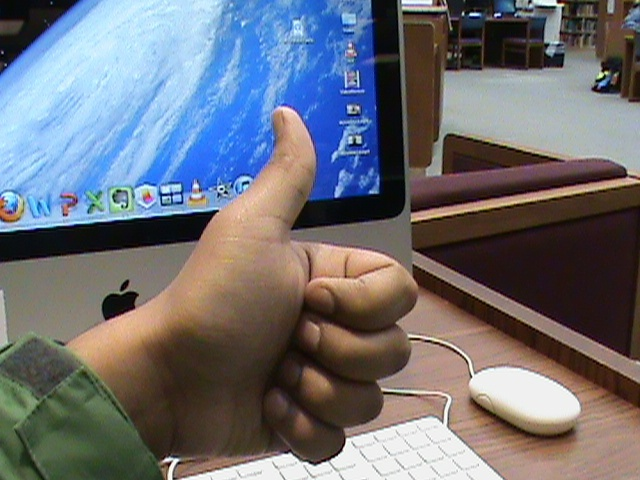Describe the objects in this image and their specific colors. I can see tv in black, lightblue, and gray tones, people in black and gray tones, keyboard in black, white, darkgray, and gray tones, mouse in black, white, gray, tan, and darkgray tones, and chair in black, maroon, and gray tones in this image. 